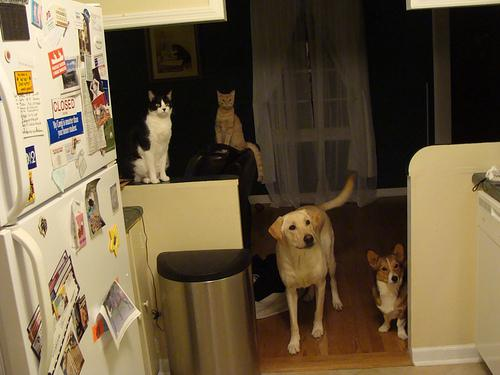Question: where is the orange cat sitting?
Choices:
A. On the couch.
B. On the wooden chair.
C. By the window.
D. On the windowsill.
Answer with the letter. Answer: A Question: how many cats are in the picture?
Choices:
A. 3.
B. 2.
C. 6.
D. 8.
Answer with the letter. Answer: B Question: what room are the animals looking into?
Choices:
A. Bedroom.
B. Bathroom.
C. Closet.
D. The Kitchen.
Answer with the letter. Answer: D Question: what kind of floor are the dogs standing on?
Choices:
A. Carpet.
B. Wood.
C. Tile.
D. Cement.
Answer with the letter. Answer: B Question: what is written on the white magnet in the middle of the fridge?
Choices:
A. Open.
B. No Smoking.
C. Closed.
D. Stop Drop and Roll.
Answer with the letter. Answer: C 